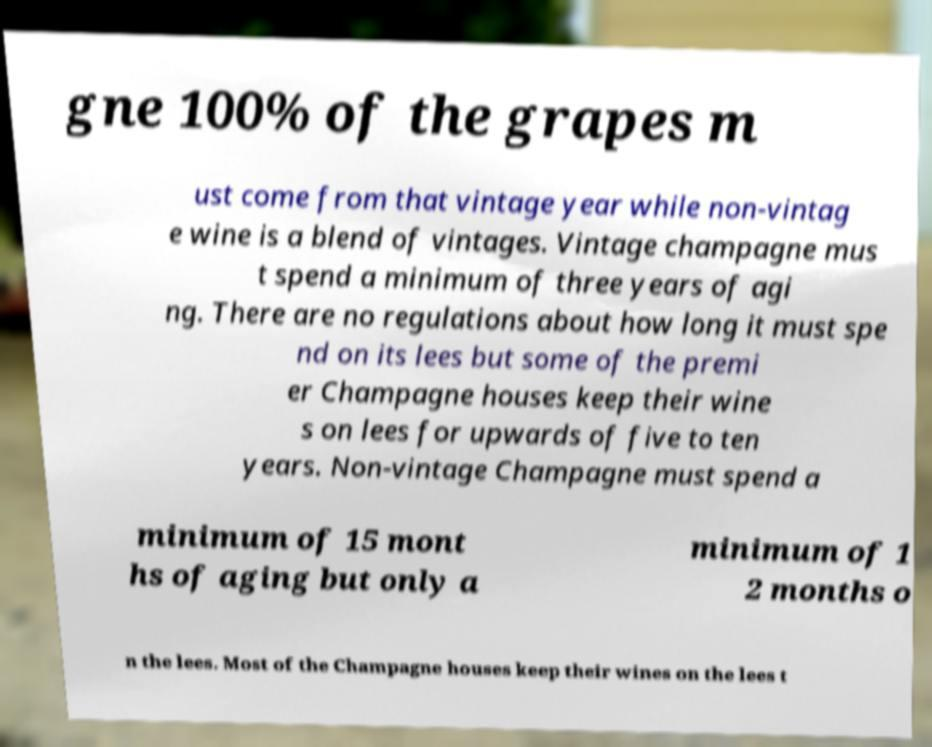Could you extract and type out the text from this image? gne 100% of the grapes m ust come from that vintage year while non-vintag e wine is a blend of vintages. Vintage champagne mus t spend a minimum of three years of agi ng. There are no regulations about how long it must spe nd on its lees but some of the premi er Champagne houses keep their wine s on lees for upwards of five to ten years. Non-vintage Champagne must spend a minimum of 15 mont hs of aging but only a minimum of 1 2 months o n the lees. Most of the Champagne houses keep their wines on the lees t 